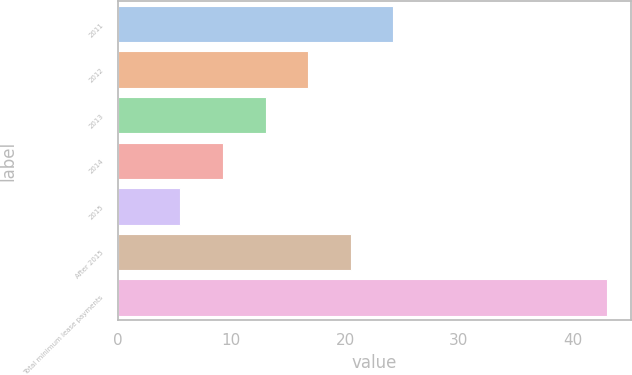Convert chart to OTSL. <chart><loc_0><loc_0><loc_500><loc_500><bar_chart><fcel>2011<fcel>2012<fcel>2013<fcel>2014<fcel>2015<fcel>After 2015<fcel>Total minimum lease payments<nl><fcel>24.25<fcel>16.75<fcel>13<fcel>9.25<fcel>5.5<fcel>20.5<fcel>43<nl></chart> 